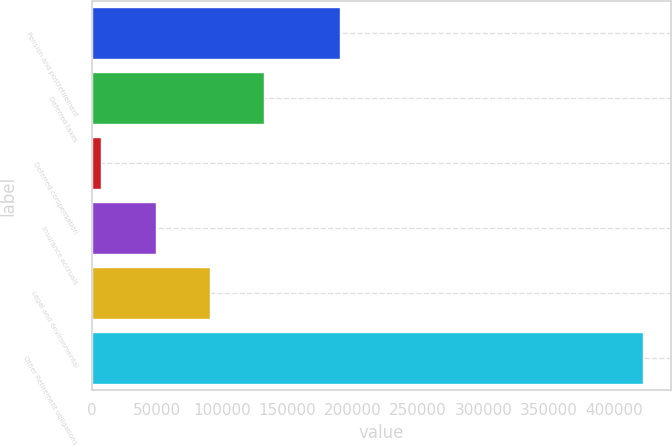Convert chart. <chart><loc_0><loc_0><loc_500><loc_500><bar_chart><fcel>Pension and postretirement<fcel>Deferred taxes<fcel>Deferred compensation<fcel>Insurance accruals<fcel>Legal and environmental<fcel>Other Retirement obligations<nl><fcel>190114<fcel>132087<fcel>7637<fcel>49120.3<fcel>90603.6<fcel>422470<nl></chart> 